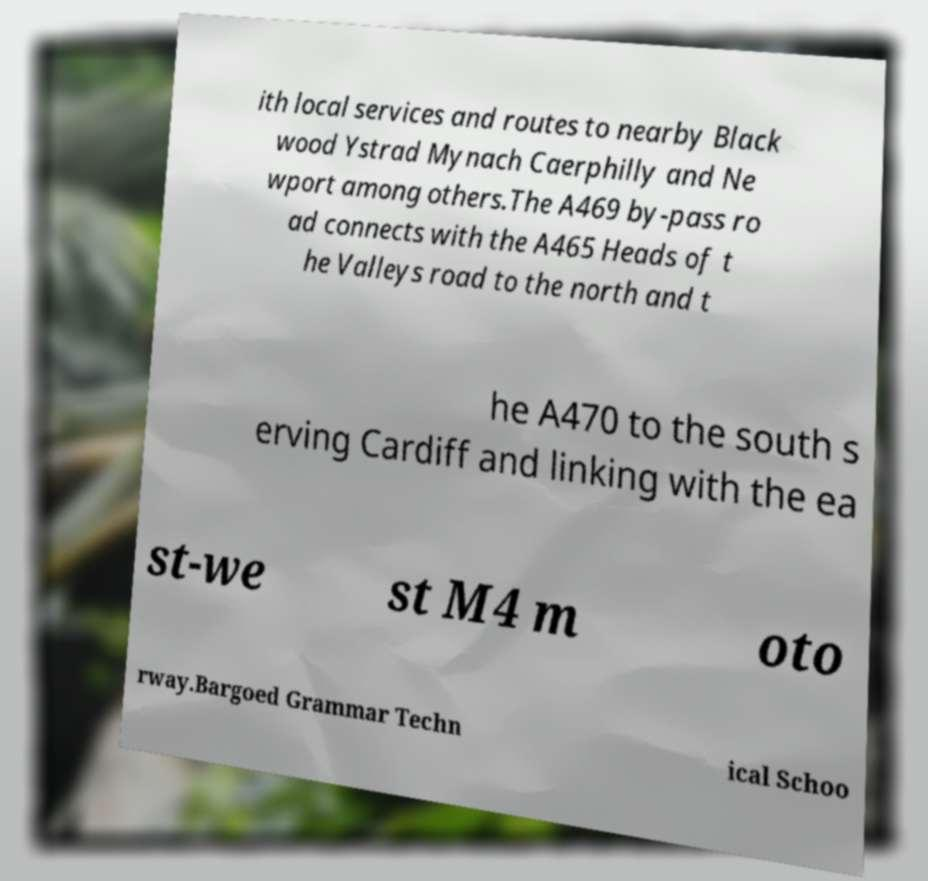Can you accurately transcribe the text from the provided image for me? ith local services and routes to nearby Black wood Ystrad Mynach Caerphilly and Ne wport among others.The A469 by-pass ro ad connects with the A465 Heads of t he Valleys road to the north and t he A470 to the south s erving Cardiff and linking with the ea st-we st M4 m oto rway.Bargoed Grammar Techn ical Schoo 